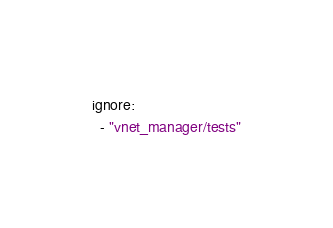<code> <loc_0><loc_0><loc_500><loc_500><_YAML_>ignore:
  - "vnet_manager/tests"
</code> 